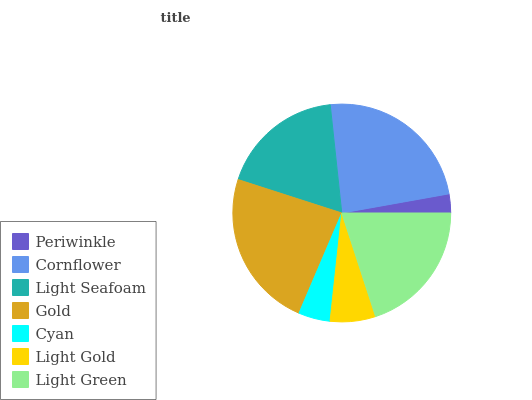Is Periwinkle the minimum?
Answer yes or no. Yes. Is Cornflower the maximum?
Answer yes or no. Yes. Is Light Seafoam the minimum?
Answer yes or no. No. Is Light Seafoam the maximum?
Answer yes or no. No. Is Cornflower greater than Light Seafoam?
Answer yes or no. Yes. Is Light Seafoam less than Cornflower?
Answer yes or no. Yes. Is Light Seafoam greater than Cornflower?
Answer yes or no. No. Is Cornflower less than Light Seafoam?
Answer yes or no. No. Is Light Seafoam the high median?
Answer yes or no. Yes. Is Light Seafoam the low median?
Answer yes or no. Yes. Is Cornflower the high median?
Answer yes or no. No. Is Light Green the low median?
Answer yes or no. No. 